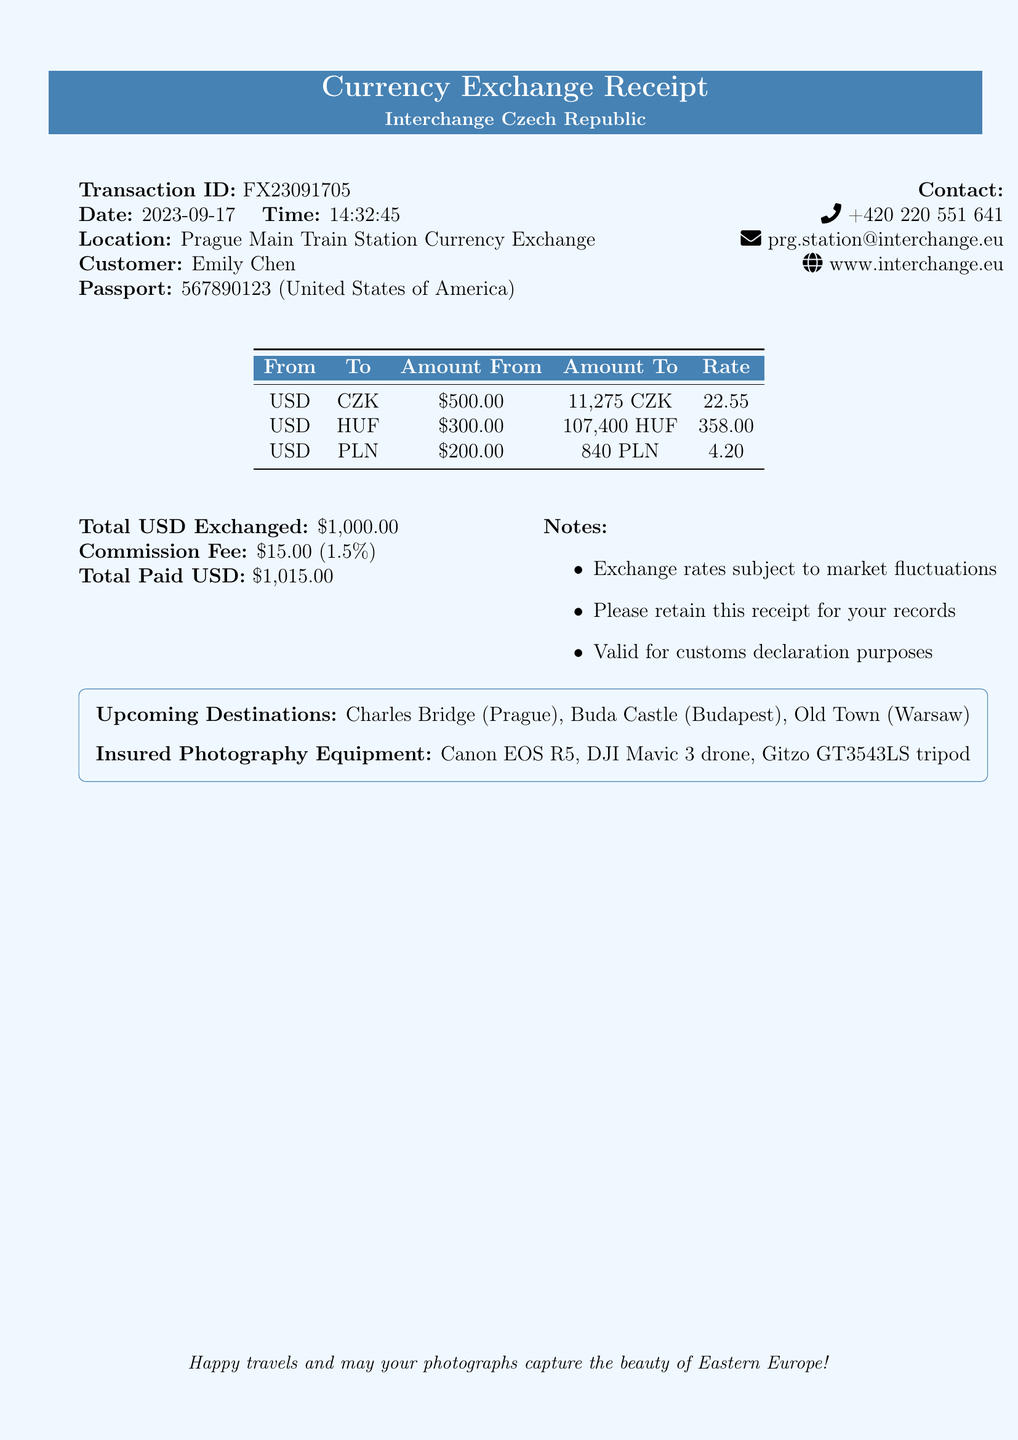What is the transaction ID? The transaction ID is a unique identifier for the currency exchange, noted as FX23091705.
Answer: FX23091705 What date was the transaction conducted? The date of the transaction is recorded in the document, which is 2023-09-17.
Answer: 2023-09-17 What is the total amount of USD exchanged? The total amount of USD exchanged during the transaction, listed in the document, is $1,000.00.
Answer: $1,000.00 How much commission was charged? The commission fee is specified as $15.00, which is calculated based on the total exchanged amount.
Answer: $15.00 What currencies were received in this exchange? The document specifies the exchanged currencies as CZK, HUF, and PLN.
Answer: CZK, HUF, PLN What was the exchange rate for USD to HUF? The exchange rate for converting USD to HUF is provided as 358.00 in the document.
Answer: 358.00 What are some upcoming destinations mentioned? The document lists specific places to visit such as Charles Bridge, Buda Castle, and Old Town.
Answer: Charles Bridge, Buda Castle, Old Town Who is the customer named in the receipt? The customer's name, as noted in the document, is Emily Chen.
Answer: Emily Chen What organization provided the currency exchange service? The exchange provider mentioned in the document is Interchange Czech Republic.
Answer: Interchange Czech Republic 